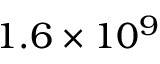Convert formula to latex. <formula><loc_0><loc_0><loc_500><loc_500>1 . 6 \times 1 0 ^ { 9 }</formula> 